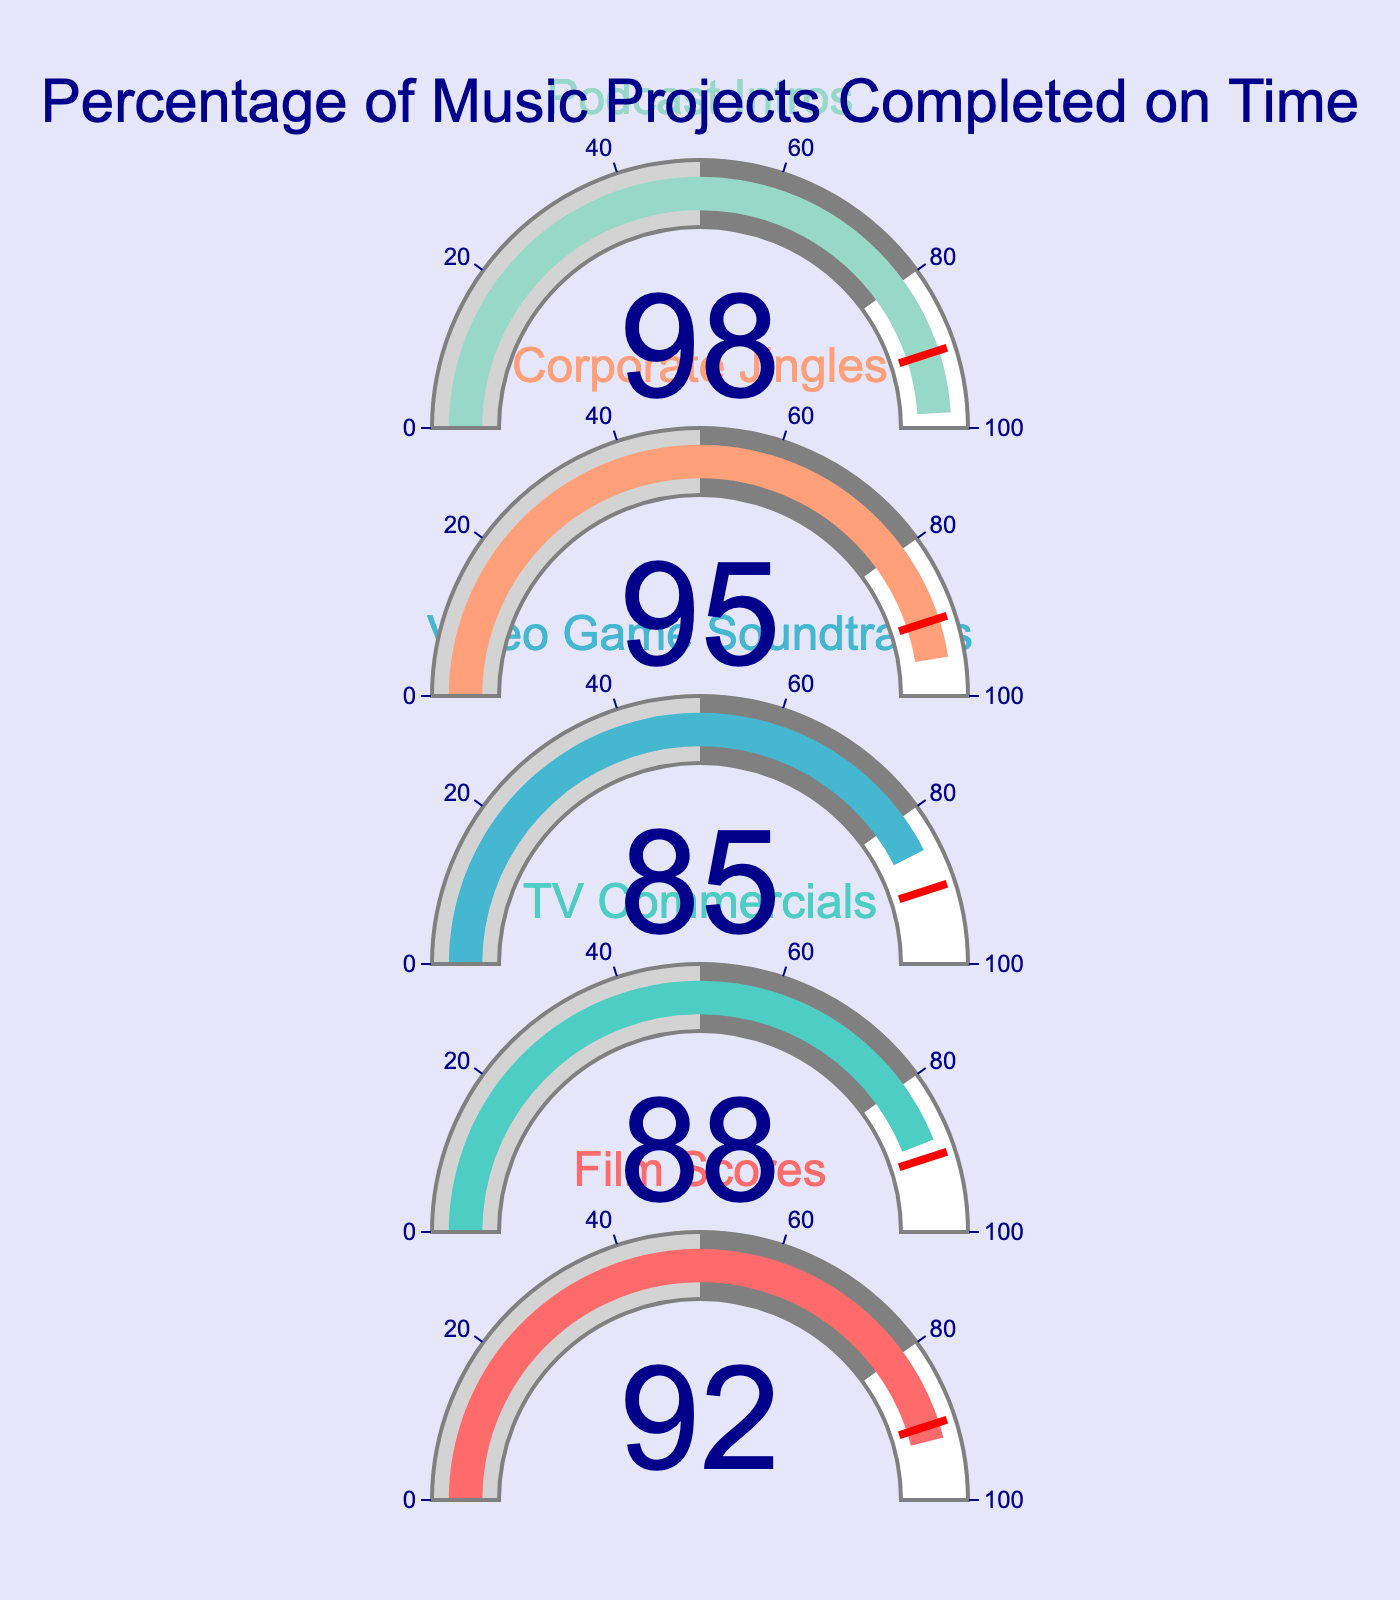What is the completion rate for corporate jingles? The gauge chart shows the completion rate for corporate jingles directly in the figure.
Answer: 95% What project has the highest completion rate? By visually inspecting the gauge charts, you can see that the podcast intros have the highest completion rate.
Answer: Podcast Intros How many projects have a completion rate above 90%? By counting the gauges with values above 90%, there are three projects: Film Scores, Corporate Jingles, and Podcast Intros.
Answer: 3 Which project has the lowest completion rate? Comparing the values on the gauges, the video game soundtracks have the lowest completion rate.
Answer: Video Game Soundtracks What is the average completion rate of all the projects? Sum the completion rates (92 + 88 + 85 + 95 + 98) and divide by the number of projects, which is 5: (92 + 88 + 85 + 95 + 98)/5 = 91.6.
Answer: 91.6% What's the difference in completion rate between TV commercials and video game soundtracks? Subtract the completion rate of video game soundtracks (85) from the completion rate of TV commercials (88): 88 - 85 = 3.
Answer: 3% How many projects have completion rates below 90%? By counting the gauges with values below 90%, there are two projects: TV Commercials and Video Game Soundtracks.
Answer: 2 What is the median completion rate of the projects? Arrange the completion rates in order (85, 88, 92, 95, 98) and find the middle value: 92 is the middle value.
Answer: 92 Which project completion rate is closest to the average completion rate of all the projects? With an average rate of 91.6%, the closest completion rate is that of the Film Scores at 92.
Answer: Film Scores 